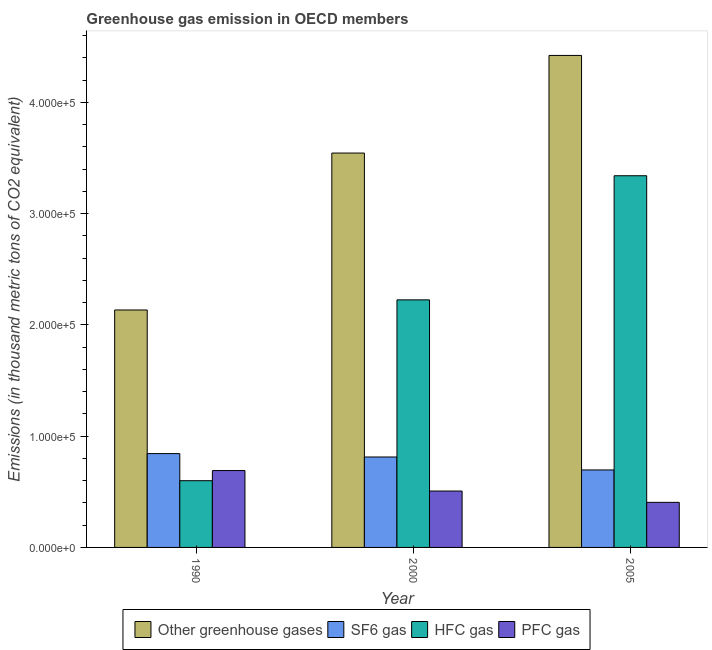How many different coloured bars are there?
Your answer should be compact. 4. How many bars are there on the 1st tick from the left?
Provide a short and direct response. 4. How many bars are there on the 1st tick from the right?
Your answer should be very brief. 4. What is the label of the 1st group of bars from the left?
Offer a terse response. 1990. In how many cases, is the number of bars for a given year not equal to the number of legend labels?
Ensure brevity in your answer.  0. What is the emission of pfc gas in 2005?
Provide a short and direct response. 4.05e+04. Across all years, what is the maximum emission of hfc gas?
Your response must be concise. 3.34e+05. Across all years, what is the minimum emission of greenhouse gases?
Your answer should be very brief. 2.13e+05. What is the total emission of sf6 gas in the graph?
Provide a short and direct response. 2.35e+05. What is the difference between the emission of pfc gas in 2000 and that in 2005?
Offer a terse response. 1.02e+04. What is the difference between the emission of sf6 gas in 1990 and the emission of greenhouse gases in 2000?
Your answer should be compact. 3071.7. What is the average emission of greenhouse gases per year?
Your answer should be very brief. 3.37e+05. In how many years, is the emission of pfc gas greater than 360000 thousand metric tons?
Ensure brevity in your answer.  0. What is the ratio of the emission of hfc gas in 1990 to that in 2000?
Your answer should be very brief. 0.27. Is the difference between the emission of hfc gas in 1990 and 2000 greater than the difference between the emission of sf6 gas in 1990 and 2000?
Your answer should be compact. No. What is the difference between the highest and the second highest emission of pfc gas?
Your response must be concise. 1.84e+04. What is the difference between the highest and the lowest emission of pfc gas?
Ensure brevity in your answer.  2.86e+04. Is the sum of the emission of greenhouse gases in 1990 and 2005 greater than the maximum emission of pfc gas across all years?
Your answer should be very brief. Yes. What does the 3rd bar from the left in 1990 represents?
Make the answer very short. HFC gas. What does the 2nd bar from the right in 1990 represents?
Keep it short and to the point. HFC gas. How many bars are there?
Your answer should be compact. 12. How many years are there in the graph?
Give a very brief answer. 3. Does the graph contain any zero values?
Make the answer very short. No. How many legend labels are there?
Keep it short and to the point. 4. How are the legend labels stacked?
Provide a short and direct response. Horizontal. What is the title of the graph?
Your response must be concise. Greenhouse gas emission in OECD members. Does "Luxembourg" appear as one of the legend labels in the graph?
Give a very brief answer. No. What is the label or title of the Y-axis?
Your answer should be very brief. Emissions (in thousand metric tons of CO2 equivalent). What is the Emissions (in thousand metric tons of CO2 equivalent) of Other greenhouse gases in 1990?
Provide a short and direct response. 2.13e+05. What is the Emissions (in thousand metric tons of CO2 equivalent) in SF6 gas in 1990?
Keep it short and to the point. 8.44e+04. What is the Emissions (in thousand metric tons of CO2 equivalent) of HFC gas in 1990?
Ensure brevity in your answer.  6.00e+04. What is the Emissions (in thousand metric tons of CO2 equivalent) in PFC gas in 1990?
Offer a very short reply. 6.91e+04. What is the Emissions (in thousand metric tons of CO2 equivalent) of Other greenhouse gases in 2000?
Your response must be concise. 3.54e+05. What is the Emissions (in thousand metric tons of CO2 equivalent) of SF6 gas in 2000?
Provide a succinct answer. 8.13e+04. What is the Emissions (in thousand metric tons of CO2 equivalent) of HFC gas in 2000?
Your response must be concise. 2.23e+05. What is the Emissions (in thousand metric tons of CO2 equivalent) in PFC gas in 2000?
Give a very brief answer. 5.07e+04. What is the Emissions (in thousand metric tons of CO2 equivalent) of Other greenhouse gases in 2005?
Provide a succinct answer. 4.42e+05. What is the Emissions (in thousand metric tons of CO2 equivalent) of SF6 gas in 2005?
Offer a terse response. 6.96e+04. What is the Emissions (in thousand metric tons of CO2 equivalent) of HFC gas in 2005?
Keep it short and to the point. 3.34e+05. What is the Emissions (in thousand metric tons of CO2 equivalent) in PFC gas in 2005?
Your answer should be compact. 4.05e+04. Across all years, what is the maximum Emissions (in thousand metric tons of CO2 equivalent) in Other greenhouse gases?
Make the answer very short. 4.42e+05. Across all years, what is the maximum Emissions (in thousand metric tons of CO2 equivalent) of SF6 gas?
Your response must be concise. 8.44e+04. Across all years, what is the maximum Emissions (in thousand metric tons of CO2 equivalent) in HFC gas?
Provide a succinct answer. 3.34e+05. Across all years, what is the maximum Emissions (in thousand metric tons of CO2 equivalent) of PFC gas?
Make the answer very short. 6.91e+04. Across all years, what is the minimum Emissions (in thousand metric tons of CO2 equivalent) of Other greenhouse gases?
Provide a succinct answer. 2.13e+05. Across all years, what is the minimum Emissions (in thousand metric tons of CO2 equivalent) in SF6 gas?
Offer a terse response. 6.96e+04. Across all years, what is the minimum Emissions (in thousand metric tons of CO2 equivalent) in HFC gas?
Your response must be concise. 6.00e+04. Across all years, what is the minimum Emissions (in thousand metric tons of CO2 equivalent) of PFC gas?
Give a very brief answer. 4.05e+04. What is the total Emissions (in thousand metric tons of CO2 equivalent) in Other greenhouse gases in the graph?
Offer a very short reply. 1.01e+06. What is the total Emissions (in thousand metric tons of CO2 equivalent) in SF6 gas in the graph?
Keep it short and to the point. 2.35e+05. What is the total Emissions (in thousand metric tons of CO2 equivalent) of HFC gas in the graph?
Your response must be concise. 6.17e+05. What is the total Emissions (in thousand metric tons of CO2 equivalent) in PFC gas in the graph?
Give a very brief answer. 1.60e+05. What is the difference between the Emissions (in thousand metric tons of CO2 equivalent) in Other greenhouse gases in 1990 and that in 2000?
Provide a short and direct response. -1.41e+05. What is the difference between the Emissions (in thousand metric tons of CO2 equivalent) of SF6 gas in 1990 and that in 2000?
Keep it short and to the point. 3071.7. What is the difference between the Emissions (in thousand metric tons of CO2 equivalent) of HFC gas in 1990 and that in 2000?
Give a very brief answer. -1.63e+05. What is the difference between the Emissions (in thousand metric tons of CO2 equivalent) in PFC gas in 1990 and that in 2000?
Provide a short and direct response. 1.84e+04. What is the difference between the Emissions (in thousand metric tons of CO2 equivalent) in Other greenhouse gases in 1990 and that in 2005?
Your answer should be compact. -2.29e+05. What is the difference between the Emissions (in thousand metric tons of CO2 equivalent) of SF6 gas in 1990 and that in 2005?
Keep it short and to the point. 1.47e+04. What is the difference between the Emissions (in thousand metric tons of CO2 equivalent) of HFC gas in 1990 and that in 2005?
Provide a succinct answer. -2.74e+05. What is the difference between the Emissions (in thousand metric tons of CO2 equivalent) of PFC gas in 1990 and that in 2005?
Your answer should be compact. 2.86e+04. What is the difference between the Emissions (in thousand metric tons of CO2 equivalent) of Other greenhouse gases in 2000 and that in 2005?
Ensure brevity in your answer.  -8.78e+04. What is the difference between the Emissions (in thousand metric tons of CO2 equivalent) of SF6 gas in 2000 and that in 2005?
Make the answer very short. 1.16e+04. What is the difference between the Emissions (in thousand metric tons of CO2 equivalent) of HFC gas in 2000 and that in 2005?
Keep it short and to the point. -1.12e+05. What is the difference between the Emissions (in thousand metric tons of CO2 equivalent) of PFC gas in 2000 and that in 2005?
Provide a short and direct response. 1.02e+04. What is the difference between the Emissions (in thousand metric tons of CO2 equivalent) of Other greenhouse gases in 1990 and the Emissions (in thousand metric tons of CO2 equivalent) of SF6 gas in 2000?
Your answer should be compact. 1.32e+05. What is the difference between the Emissions (in thousand metric tons of CO2 equivalent) of Other greenhouse gases in 1990 and the Emissions (in thousand metric tons of CO2 equivalent) of HFC gas in 2000?
Make the answer very short. -9085.8. What is the difference between the Emissions (in thousand metric tons of CO2 equivalent) in Other greenhouse gases in 1990 and the Emissions (in thousand metric tons of CO2 equivalent) in PFC gas in 2000?
Give a very brief answer. 1.63e+05. What is the difference between the Emissions (in thousand metric tons of CO2 equivalent) in SF6 gas in 1990 and the Emissions (in thousand metric tons of CO2 equivalent) in HFC gas in 2000?
Provide a succinct answer. -1.38e+05. What is the difference between the Emissions (in thousand metric tons of CO2 equivalent) in SF6 gas in 1990 and the Emissions (in thousand metric tons of CO2 equivalent) in PFC gas in 2000?
Provide a short and direct response. 3.37e+04. What is the difference between the Emissions (in thousand metric tons of CO2 equivalent) of HFC gas in 1990 and the Emissions (in thousand metric tons of CO2 equivalent) of PFC gas in 2000?
Your answer should be compact. 9302.6. What is the difference between the Emissions (in thousand metric tons of CO2 equivalent) of Other greenhouse gases in 1990 and the Emissions (in thousand metric tons of CO2 equivalent) of SF6 gas in 2005?
Your answer should be compact. 1.44e+05. What is the difference between the Emissions (in thousand metric tons of CO2 equivalent) of Other greenhouse gases in 1990 and the Emissions (in thousand metric tons of CO2 equivalent) of HFC gas in 2005?
Make the answer very short. -1.21e+05. What is the difference between the Emissions (in thousand metric tons of CO2 equivalent) of Other greenhouse gases in 1990 and the Emissions (in thousand metric tons of CO2 equivalent) of PFC gas in 2005?
Your answer should be very brief. 1.73e+05. What is the difference between the Emissions (in thousand metric tons of CO2 equivalent) of SF6 gas in 1990 and the Emissions (in thousand metric tons of CO2 equivalent) of HFC gas in 2005?
Provide a succinct answer. -2.50e+05. What is the difference between the Emissions (in thousand metric tons of CO2 equivalent) of SF6 gas in 1990 and the Emissions (in thousand metric tons of CO2 equivalent) of PFC gas in 2005?
Provide a short and direct response. 4.38e+04. What is the difference between the Emissions (in thousand metric tons of CO2 equivalent) of HFC gas in 1990 and the Emissions (in thousand metric tons of CO2 equivalent) of PFC gas in 2005?
Provide a succinct answer. 1.95e+04. What is the difference between the Emissions (in thousand metric tons of CO2 equivalent) of Other greenhouse gases in 2000 and the Emissions (in thousand metric tons of CO2 equivalent) of SF6 gas in 2005?
Your answer should be compact. 2.85e+05. What is the difference between the Emissions (in thousand metric tons of CO2 equivalent) in Other greenhouse gases in 2000 and the Emissions (in thousand metric tons of CO2 equivalent) in HFC gas in 2005?
Provide a succinct answer. 2.04e+04. What is the difference between the Emissions (in thousand metric tons of CO2 equivalent) of Other greenhouse gases in 2000 and the Emissions (in thousand metric tons of CO2 equivalent) of PFC gas in 2005?
Give a very brief answer. 3.14e+05. What is the difference between the Emissions (in thousand metric tons of CO2 equivalent) in SF6 gas in 2000 and the Emissions (in thousand metric tons of CO2 equivalent) in HFC gas in 2005?
Give a very brief answer. -2.53e+05. What is the difference between the Emissions (in thousand metric tons of CO2 equivalent) of SF6 gas in 2000 and the Emissions (in thousand metric tons of CO2 equivalent) of PFC gas in 2005?
Provide a short and direct response. 4.08e+04. What is the difference between the Emissions (in thousand metric tons of CO2 equivalent) in HFC gas in 2000 and the Emissions (in thousand metric tons of CO2 equivalent) in PFC gas in 2005?
Give a very brief answer. 1.82e+05. What is the average Emissions (in thousand metric tons of CO2 equivalent) in Other greenhouse gases per year?
Offer a terse response. 3.37e+05. What is the average Emissions (in thousand metric tons of CO2 equivalent) of SF6 gas per year?
Offer a terse response. 7.84e+04. What is the average Emissions (in thousand metric tons of CO2 equivalent) of HFC gas per year?
Provide a short and direct response. 2.06e+05. What is the average Emissions (in thousand metric tons of CO2 equivalent) of PFC gas per year?
Provide a succinct answer. 5.34e+04. In the year 1990, what is the difference between the Emissions (in thousand metric tons of CO2 equivalent) in Other greenhouse gases and Emissions (in thousand metric tons of CO2 equivalent) in SF6 gas?
Offer a terse response. 1.29e+05. In the year 1990, what is the difference between the Emissions (in thousand metric tons of CO2 equivalent) of Other greenhouse gases and Emissions (in thousand metric tons of CO2 equivalent) of HFC gas?
Offer a terse response. 1.53e+05. In the year 1990, what is the difference between the Emissions (in thousand metric tons of CO2 equivalent) of Other greenhouse gases and Emissions (in thousand metric tons of CO2 equivalent) of PFC gas?
Your answer should be very brief. 1.44e+05. In the year 1990, what is the difference between the Emissions (in thousand metric tons of CO2 equivalent) in SF6 gas and Emissions (in thousand metric tons of CO2 equivalent) in HFC gas?
Offer a terse response. 2.44e+04. In the year 1990, what is the difference between the Emissions (in thousand metric tons of CO2 equivalent) in SF6 gas and Emissions (in thousand metric tons of CO2 equivalent) in PFC gas?
Ensure brevity in your answer.  1.53e+04. In the year 1990, what is the difference between the Emissions (in thousand metric tons of CO2 equivalent) in HFC gas and Emissions (in thousand metric tons of CO2 equivalent) in PFC gas?
Your answer should be compact. -9114.4. In the year 2000, what is the difference between the Emissions (in thousand metric tons of CO2 equivalent) in Other greenhouse gases and Emissions (in thousand metric tons of CO2 equivalent) in SF6 gas?
Your response must be concise. 2.73e+05. In the year 2000, what is the difference between the Emissions (in thousand metric tons of CO2 equivalent) in Other greenhouse gases and Emissions (in thousand metric tons of CO2 equivalent) in HFC gas?
Offer a very short reply. 1.32e+05. In the year 2000, what is the difference between the Emissions (in thousand metric tons of CO2 equivalent) in Other greenhouse gases and Emissions (in thousand metric tons of CO2 equivalent) in PFC gas?
Make the answer very short. 3.04e+05. In the year 2000, what is the difference between the Emissions (in thousand metric tons of CO2 equivalent) in SF6 gas and Emissions (in thousand metric tons of CO2 equivalent) in HFC gas?
Your answer should be very brief. -1.41e+05. In the year 2000, what is the difference between the Emissions (in thousand metric tons of CO2 equivalent) of SF6 gas and Emissions (in thousand metric tons of CO2 equivalent) of PFC gas?
Provide a short and direct response. 3.06e+04. In the year 2000, what is the difference between the Emissions (in thousand metric tons of CO2 equivalent) of HFC gas and Emissions (in thousand metric tons of CO2 equivalent) of PFC gas?
Offer a terse response. 1.72e+05. In the year 2005, what is the difference between the Emissions (in thousand metric tons of CO2 equivalent) in Other greenhouse gases and Emissions (in thousand metric tons of CO2 equivalent) in SF6 gas?
Your answer should be very brief. 3.73e+05. In the year 2005, what is the difference between the Emissions (in thousand metric tons of CO2 equivalent) in Other greenhouse gases and Emissions (in thousand metric tons of CO2 equivalent) in HFC gas?
Give a very brief answer. 1.08e+05. In the year 2005, what is the difference between the Emissions (in thousand metric tons of CO2 equivalent) of Other greenhouse gases and Emissions (in thousand metric tons of CO2 equivalent) of PFC gas?
Provide a short and direct response. 4.02e+05. In the year 2005, what is the difference between the Emissions (in thousand metric tons of CO2 equivalent) of SF6 gas and Emissions (in thousand metric tons of CO2 equivalent) of HFC gas?
Ensure brevity in your answer.  -2.64e+05. In the year 2005, what is the difference between the Emissions (in thousand metric tons of CO2 equivalent) in SF6 gas and Emissions (in thousand metric tons of CO2 equivalent) in PFC gas?
Offer a very short reply. 2.91e+04. In the year 2005, what is the difference between the Emissions (in thousand metric tons of CO2 equivalent) in HFC gas and Emissions (in thousand metric tons of CO2 equivalent) in PFC gas?
Provide a short and direct response. 2.94e+05. What is the ratio of the Emissions (in thousand metric tons of CO2 equivalent) of Other greenhouse gases in 1990 to that in 2000?
Keep it short and to the point. 0.6. What is the ratio of the Emissions (in thousand metric tons of CO2 equivalent) of SF6 gas in 1990 to that in 2000?
Make the answer very short. 1.04. What is the ratio of the Emissions (in thousand metric tons of CO2 equivalent) of HFC gas in 1990 to that in 2000?
Offer a terse response. 0.27. What is the ratio of the Emissions (in thousand metric tons of CO2 equivalent) in PFC gas in 1990 to that in 2000?
Make the answer very short. 1.36. What is the ratio of the Emissions (in thousand metric tons of CO2 equivalent) of Other greenhouse gases in 1990 to that in 2005?
Ensure brevity in your answer.  0.48. What is the ratio of the Emissions (in thousand metric tons of CO2 equivalent) in SF6 gas in 1990 to that in 2005?
Your response must be concise. 1.21. What is the ratio of the Emissions (in thousand metric tons of CO2 equivalent) in HFC gas in 1990 to that in 2005?
Ensure brevity in your answer.  0.18. What is the ratio of the Emissions (in thousand metric tons of CO2 equivalent) of PFC gas in 1990 to that in 2005?
Keep it short and to the point. 1.71. What is the ratio of the Emissions (in thousand metric tons of CO2 equivalent) of Other greenhouse gases in 2000 to that in 2005?
Your answer should be compact. 0.8. What is the ratio of the Emissions (in thousand metric tons of CO2 equivalent) of SF6 gas in 2000 to that in 2005?
Your answer should be very brief. 1.17. What is the ratio of the Emissions (in thousand metric tons of CO2 equivalent) in HFC gas in 2000 to that in 2005?
Offer a terse response. 0.67. What is the ratio of the Emissions (in thousand metric tons of CO2 equivalent) in PFC gas in 2000 to that in 2005?
Ensure brevity in your answer.  1.25. What is the difference between the highest and the second highest Emissions (in thousand metric tons of CO2 equivalent) in Other greenhouse gases?
Offer a terse response. 8.78e+04. What is the difference between the highest and the second highest Emissions (in thousand metric tons of CO2 equivalent) in SF6 gas?
Offer a very short reply. 3071.7. What is the difference between the highest and the second highest Emissions (in thousand metric tons of CO2 equivalent) of HFC gas?
Keep it short and to the point. 1.12e+05. What is the difference between the highest and the second highest Emissions (in thousand metric tons of CO2 equivalent) in PFC gas?
Give a very brief answer. 1.84e+04. What is the difference between the highest and the lowest Emissions (in thousand metric tons of CO2 equivalent) in Other greenhouse gases?
Provide a short and direct response. 2.29e+05. What is the difference between the highest and the lowest Emissions (in thousand metric tons of CO2 equivalent) of SF6 gas?
Offer a terse response. 1.47e+04. What is the difference between the highest and the lowest Emissions (in thousand metric tons of CO2 equivalent) in HFC gas?
Your answer should be compact. 2.74e+05. What is the difference between the highest and the lowest Emissions (in thousand metric tons of CO2 equivalent) in PFC gas?
Offer a very short reply. 2.86e+04. 